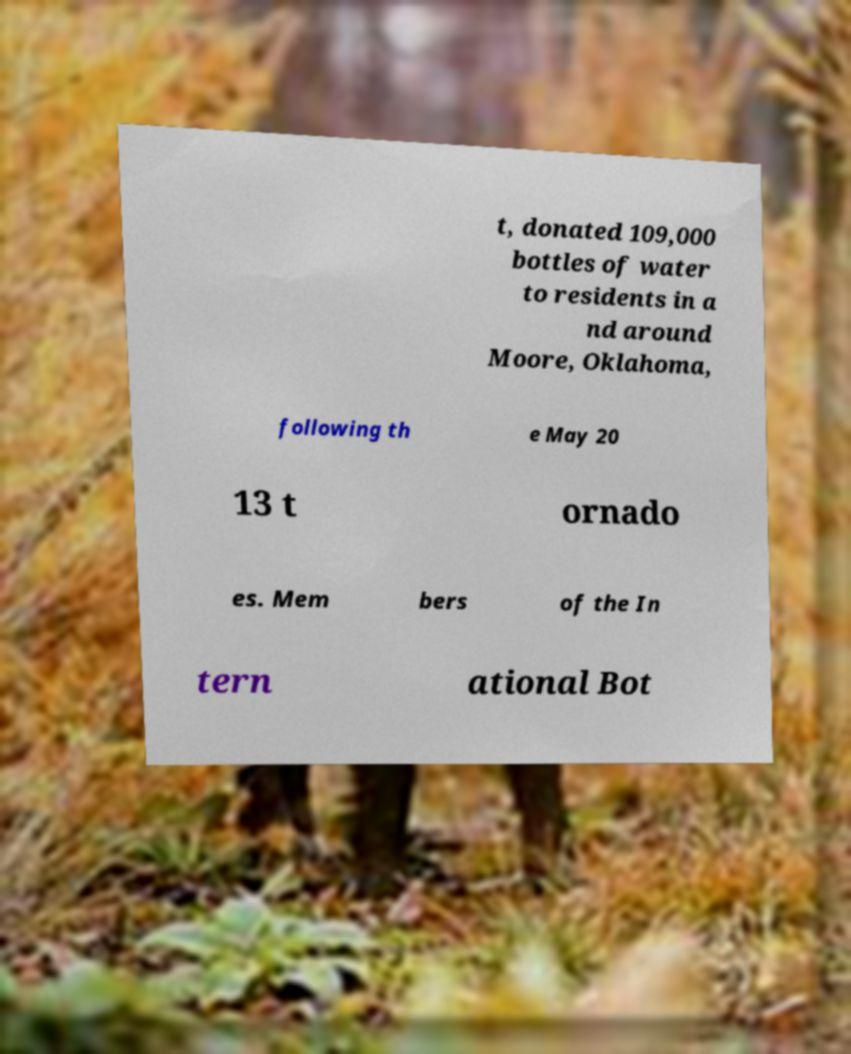There's text embedded in this image that I need extracted. Can you transcribe it verbatim? t, donated 109,000 bottles of water to residents in a nd around Moore, Oklahoma, following th e May 20 13 t ornado es. Mem bers of the In tern ational Bot 